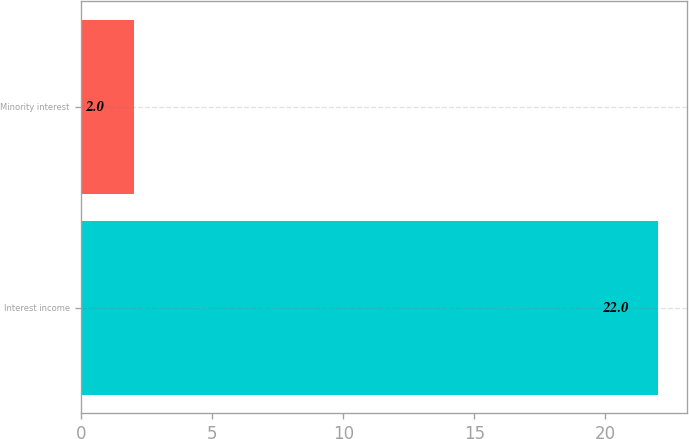<chart> <loc_0><loc_0><loc_500><loc_500><bar_chart><fcel>Interest income<fcel>Minority interest<nl><fcel>22<fcel>2<nl></chart> 